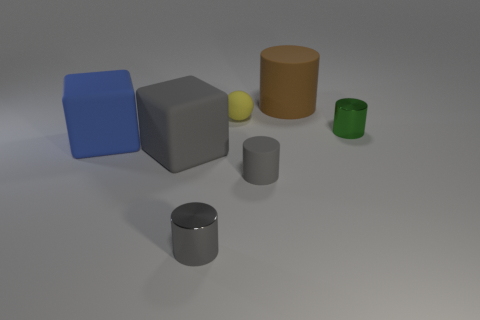Is the ball the same color as the small matte cylinder?
Your answer should be very brief. No. How many balls are small objects or brown things?
Your answer should be very brief. 1. What is the material of the tiny cylinder that is both in front of the gray rubber cube and on the right side of the small yellow thing?
Offer a very short reply. Rubber. There is a big blue rubber block; how many cylinders are in front of it?
Offer a very short reply. 2. Is the tiny cylinder behind the large blue block made of the same material as the large thing that is behind the blue block?
Provide a short and direct response. No. How many objects are either cylinders that are on the left side of the yellow object or small gray metal cylinders?
Give a very brief answer. 1. Is the number of big blue matte things that are on the right side of the gray shiny cylinder less than the number of blue cubes that are behind the green object?
Provide a succinct answer. No. What number of other things are there of the same size as the brown thing?
Your answer should be compact. 2. Do the brown cylinder and the small gray cylinder left of the gray rubber cylinder have the same material?
Your response must be concise. No. What number of objects are either cylinders to the left of the large brown rubber thing or rubber cylinders that are in front of the blue rubber cube?
Keep it short and to the point. 2. 